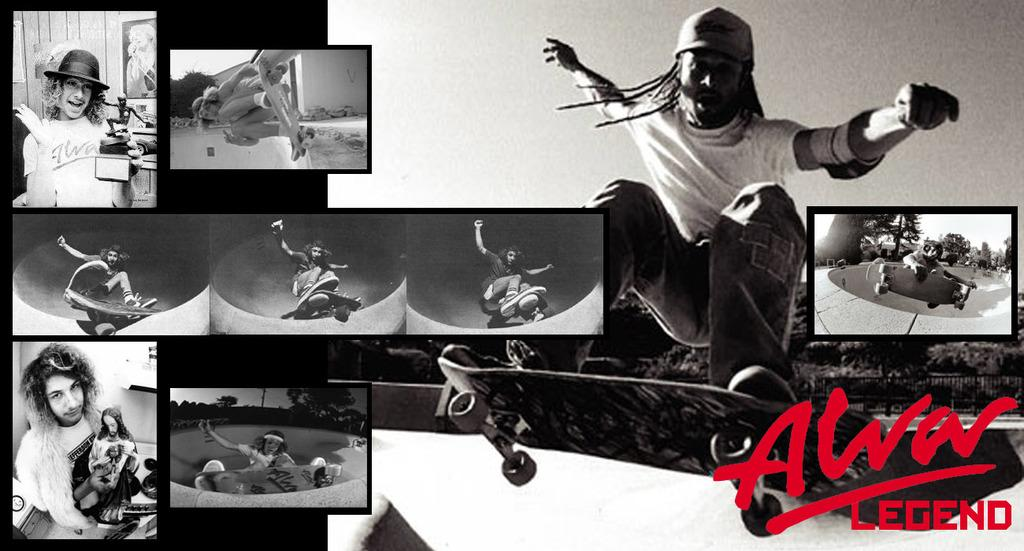What activity is the person in the image engaged in? The person is riding a skateboard in the image. What else can be seen in the image besides the person on the skateboard? There are pictures of persons and text at the bottom of the image. What type of invention is being showcased in the image? There is no invention being showcased in the image; it features a person riding a skateboard and other elements. What angle is the skateboard being viewed from in the image? The angle from which the skateboard is being viewed cannot be determined from the image. 